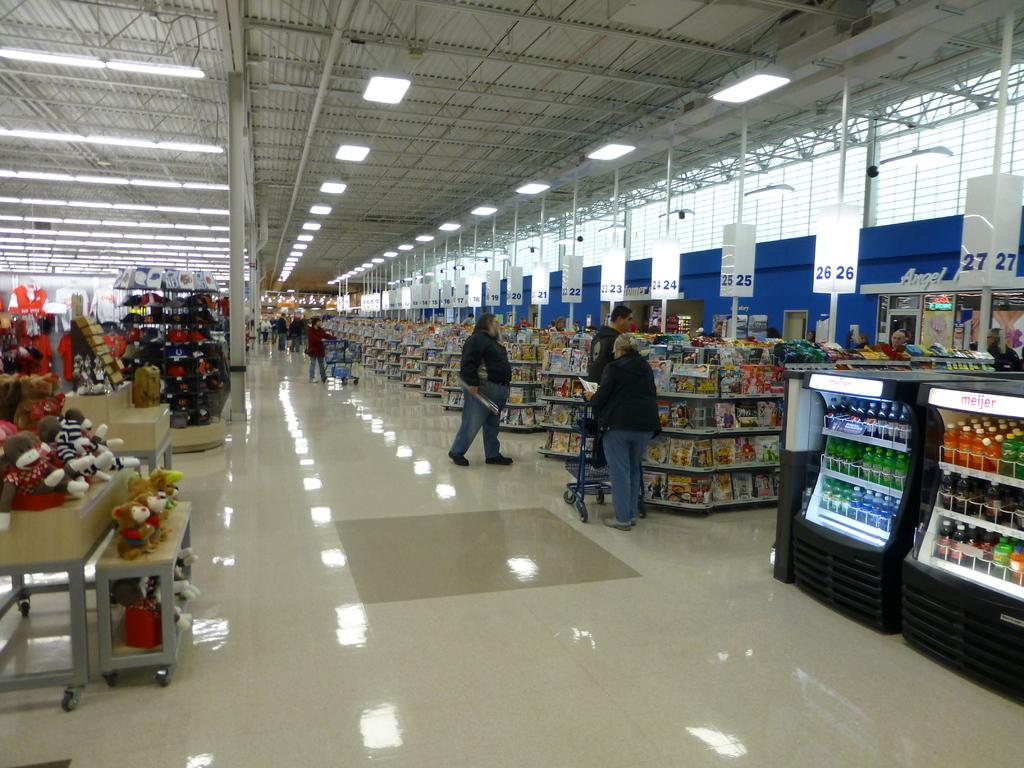<image>
Provide a brief description of the given image. People are checking out at an Angel market store. 